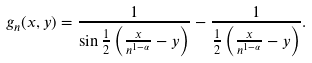Convert formula to latex. <formula><loc_0><loc_0><loc_500><loc_500>g _ { n } ( x , y ) = \frac { 1 } { \sin \frac { 1 } { 2 } \left ( \frac { x } { n ^ { 1 - \alpha } } - y \right ) } - \frac { 1 } { \frac { 1 } { 2 } \left ( \frac { x } { n ^ { 1 - \alpha } } - y \right ) } .</formula> 